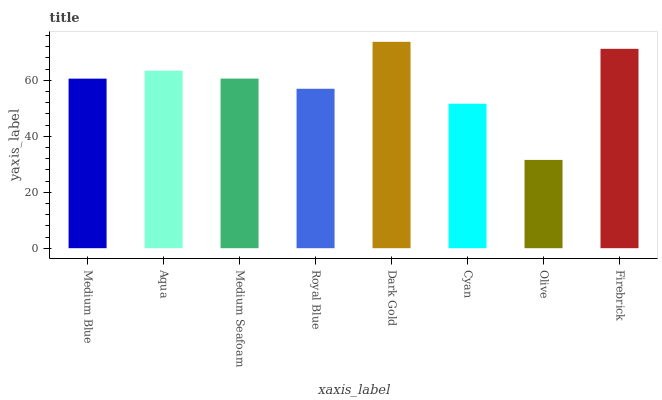Is Olive the minimum?
Answer yes or no. Yes. Is Dark Gold the maximum?
Answer yes or no. Yes. Is Aqua the minimum?
Answer yes or no. No. Is Aqua the maximum?
Answer yes or no. No. Is Aqua greater than Medium Blue?
Answer yes or no. Yes. Is Medium Blue less than Aqua?
Answer yes or no. Yes. Is Medium Blue greater than Aqua?
Answer yes or no. No. Is Aqua less than Medium Blue?
Answer yes or no. No. Is Medium Seafoam the high median?
Answer yes or no. Yes. Is Medium Blue the low median?
Answer yes or no. Yes. Is Olive the high median?
Answer yes or no. No. Is Dark Gold the low median?
Answer yes or no. No. 